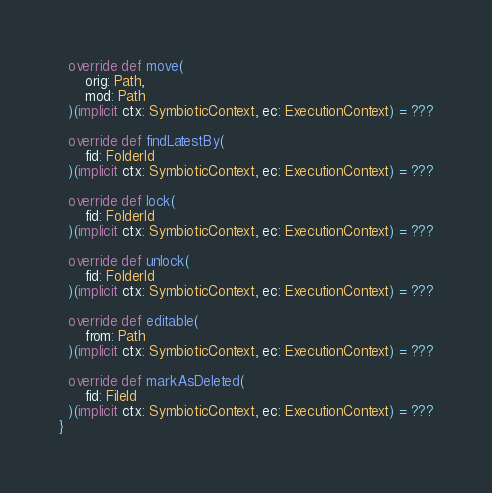<code> <loc_0><loc_0><loc_500><loc_500><_Scala_>
  override def move(
      orig: Path,
      mod: Path
  )(implicit ctx: SymbioticContext, ec: ExecutionContext) = ???

  override def findLatestBy(
      fid: FolderId
  )(implicit ctx: SymbioticContext, ec: ExecutionContext) = ???

  override def lock(
      fid: FolderId
  )(implicit ctx: SymbioticContext, ec: ExecutionContext) = ???

  override def unlock(
      fid: FolderId
  )(implicit ctx: SymbioticContext, ec: ExecutionContext) = ???

  override def editable(
      from: Path
  )(implicit ctx: SymbioticContext, ec: ExecutionContext) = ???

  override def markAsDeleted(
      fid: FileId
  )(implicit ctx: SymbioticContext, ec: ExecutionContext) = ???
}
</code> 